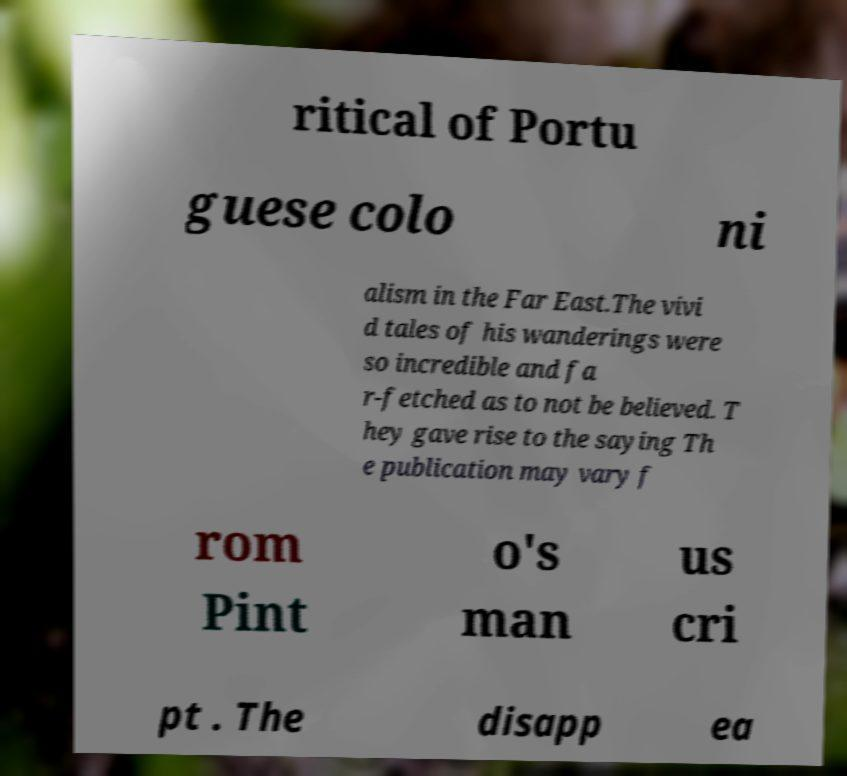I need the written content from this picture converted into text. Can you do that? ritical of Portu guese colo ni alism in the Far East.The vivi d tales of his wanderings were so incredible and fa r-fetched as to not be believed. T hey gave rise to the saying Th e publication may vary f rom Pint o's man us cri pt . The disapp ea 